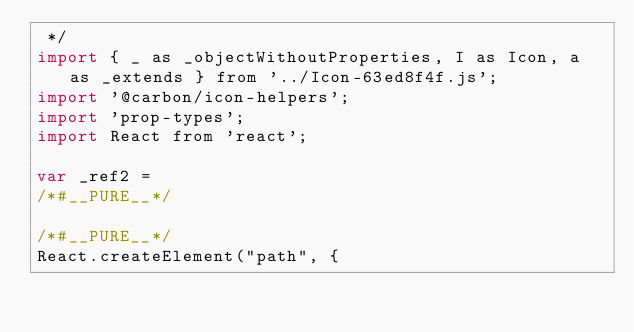<code> <loc_0><loc_0><loc_500><loc_500><_JavaScript_> */
import { _ as _objectWithoutProperties, I as Icon, a as _extends } from '../Icon-63ed8f4f.js';
import '@carbon/icon-helpers';
import 'prop-types';
import React from 'react';

var _ref2 =
/*#__PURE__*/

/*#__PURE__*/
React.createElement("path", {</code> 